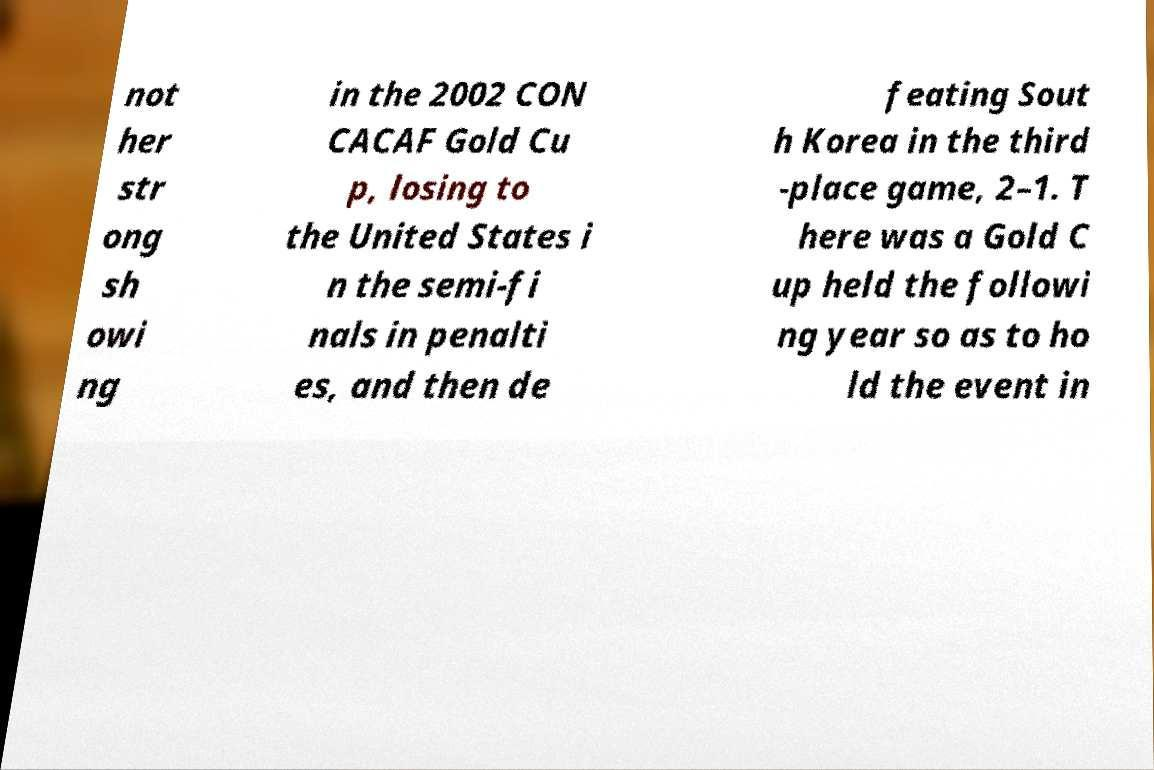Please read and relay the text visible in this image. What does it say? not her str ong sh owi ng in the 2002 CON CACAF Gold Cu p, losing to the United States i n the semi-fi nals in penalti es, and then de feating Sout h Korea in the third -place game, 2–1. T here was a Gold C up held the followi ng year so as to ho ld the event in 